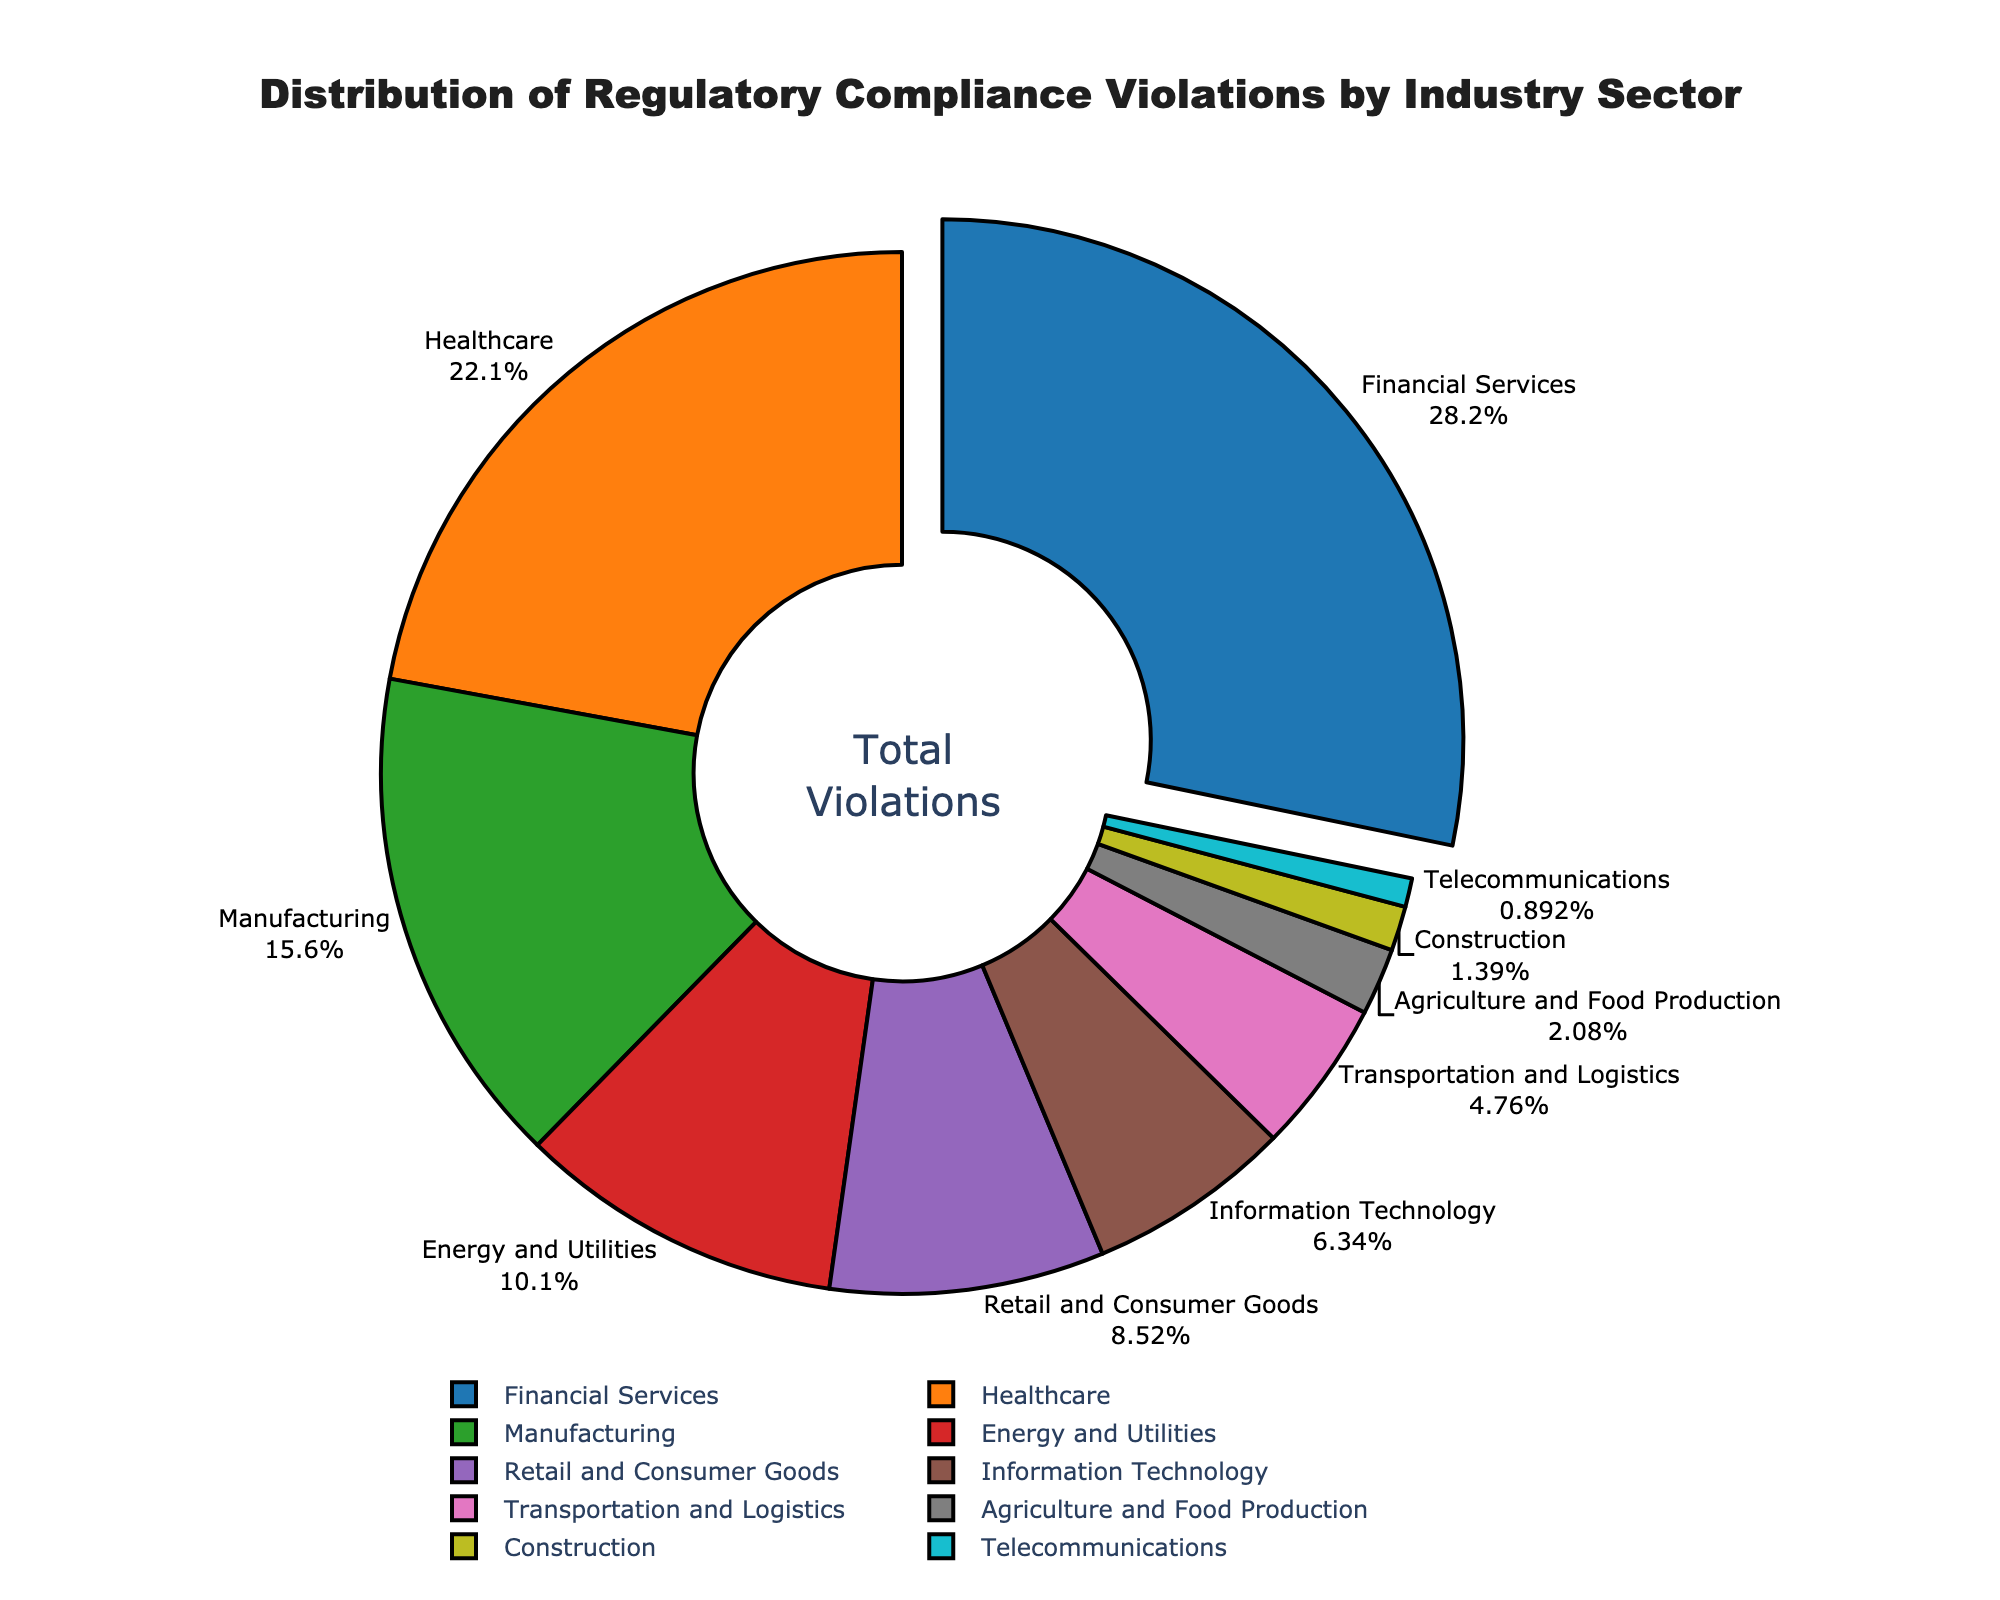What industry sector has the highest percentage of regulatory compliance violations? The Financial Services sector has the largest segment in the pie chart, which indicates the highest percentage of violations.
Answer: Financial Services Which two industry sectors combined have just over 50% of the violations? The pie chart shows that Financial Services and Healthcare sectors have the top two percentages. Adding them together results in 28.5% + 22.3% = 50.8%.
Answer: Financial Services and Healthcare How does the percentage of violations in Manufacturing compare to that in Retail and Consumer Goods? The pie chart reveals that Manufacturing has 15.7% and Retail and Consumer Goods has 8.6%. Manufacturing has a higher percentage by 7.1%.
Answer: Manufacturing has a higher percentage What is the difference between the sector with the highest violations and the sector with the lowest violations? The Financial Services sector has the highest percentage (28.5%) and the Telecommunications sector has the lowest (0.9%), so the difference is 28.5% - 0.9% = 27.6%.
Answer: 27.6% Which sector has slightly more violations, Energy and Utilities or Information Technology? The pie chart indicates that Energy and Utilities have 10.2% while Information Technology has 6.4%. Energy and Utilities have a higher percentage by 3.8%.
Answer: Energy and Utilities What is the combined percentage of violations for the four smallest sectors in the chart? The smallest sectors are Construction (1.4%), Telecommunications (0.9%), Agriculture and Food Production (2.1%), and Transportation and Logistics (4.8%). Adding these together: 1.4% + 0.9% + 2.1% + 4.8% = 9.2%.
Answer: 9.2% How does the size of the segment for Healthcare compare visually to that of Information Technology? Healthcare has a larger segment in the pie chart compared to Information Technology. This visual difference indicates that Healthcare has a higher percentage.
Answer: Healthcare has a larger segment If the percentage of violations in the Telecommunications and Healthcare sectors were summed, what would be the total? The pie chart shows Telecommunications has 0.9% and Healthcare has 22.3%. Summing these results in 0.9% + 22.3% = 23.2%.
Answer: 23.2% What color represents the Financial Services sector in the chart? The Financial Services segment is colored blue in the pie chart.
Answer: Blue 